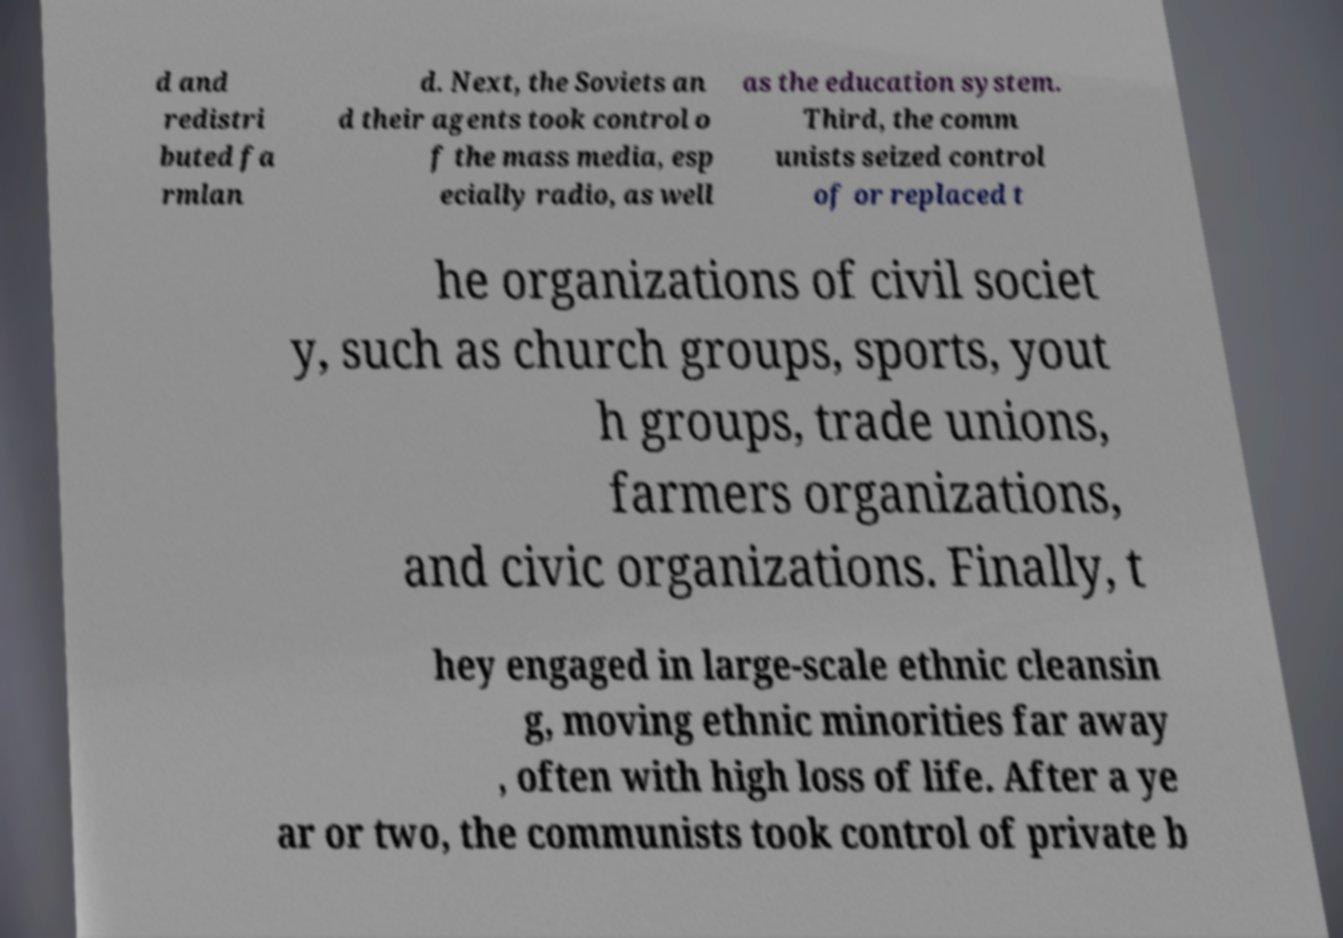Please identify and transcribe the text found in this image. d and redistri buted fa rmlan d. Next, the Soviets an d their agents took control o f the mass media, esp ecially radio, as well as the education system. Third, the comm unists seized control of or replaced t he organizations of civil societ y, such as church groups, sports, yout h groups, trade unions, farmers organizations, and civic organizations. Finally, t hey engaged in large-scale ethnic cleansin g, moving ethnic minorities far away , often with high loss of life. After a ye ar or two, the communists took control of private b 